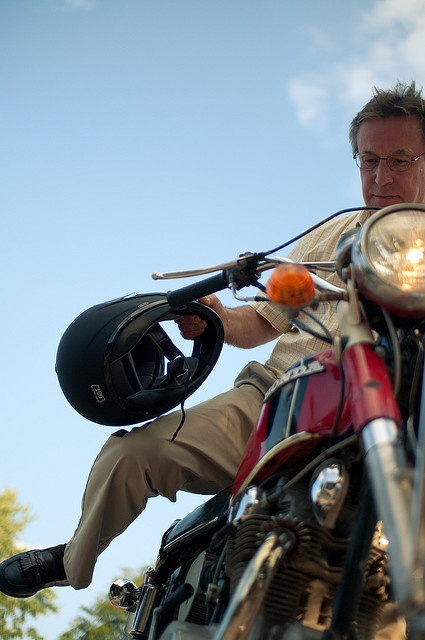Describe the objects in this image and their specific colors. I can see motorcycle in lightblue, black, gray, maroon, and darkgray tones and people in lightblue, gray, black, and maroon tones in this image. 